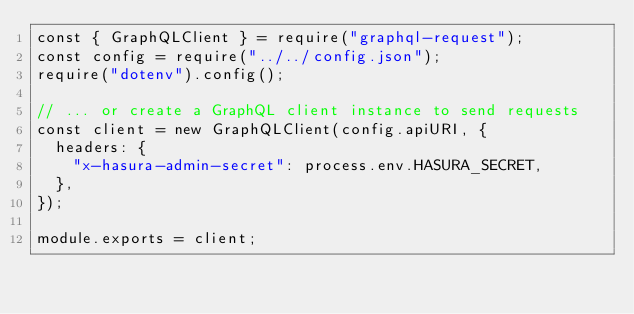Convert code to text. <code><loc_0><loc_0><loc_500><loc_500><_JavaScript_>const { GraphQLClient } = require("graphql-request");
const config = require("../../config.json");
require("dotenv").config();

// ... or create a GraphQL client instance to send requests
const client = new GraphQLClient(config.apiURI, {
  headers: {
    "x-hasura-admin-secret": process.env.HASURA_SECRET,
  },
});

module.exports = client;
</code> 